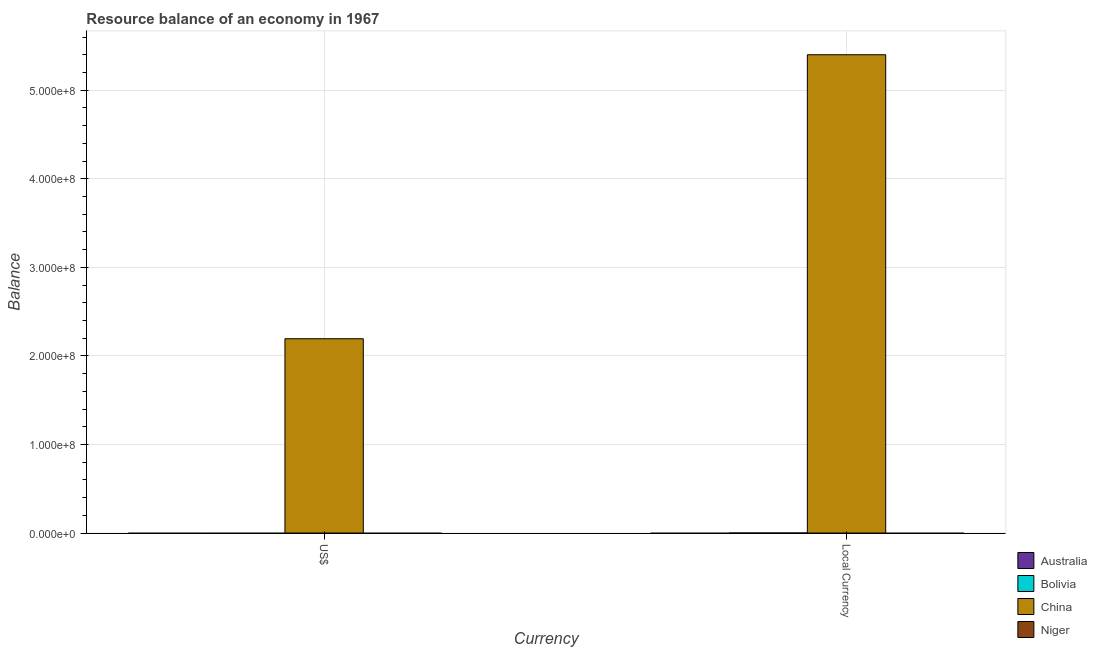How many different coloured bars are there?
Make the answer very short. 1. How many bars are there on the 1st tick from the right?
Offer a terse response. 1. What is the label of the 1st group of bars from the left?
Provide a succinct answer. US$. Across all countries, what is the maximum resource balance in constant us$?
Provide a succinct answer. 5.40e+08. What is the total resource balance in constant us$ in the graph?
Keep it short and to the point. 5.40e+08. What is the difference between the resource balance in us$ in Australia and the resource balance in constant us$ in Bolivia?
Provide a succinct answer. 0. What is the average resource balance in us$ per country?
Offer a very short reply. 5.48e+07. What is the difference between the resource balance in constant us$ and resource balance in us$ in China?
Your answer should be compact. 3.21e+08. In how many countries, is the resource balance in constant us$ greater than 500000000 units?
Provide a succinct answer. 1. How many bars are there?
Keep it short and to the point. 2. Are all the bars in the graph horizontal?
Offer a very short reply. No. How many countries are there in the graph?
Keep it short and to the point. 4. Are the values on the major ticks of Y-axis written in scientific E-notation?
Your response must be concise. Yes. Does the graph contain any zero values?
Keep it short and to the point. Yes. Where does the legend appear in the graph?
Offer a terse response. Bottom right. How many legend labels are there?
Your response must be concise. 4. How are the legend labels stacked?
Offer a very short reply. Vertical. What is the title of the graph?
Offer a terse response. Resource balance of an economy in 1967. What is the label or title of the X-axis?
Your answer should be compact. Currency. What is the label or title of the Y-axis?
Your answer should be compact. Balance. What is the Balance of Australia in US$?
Provide a short and direct response. 0. What is the Balance in China in US$?
Give a very brief answer. 2.19e+08. What is the Balance in Australia in Local Currency?
Your answer should be compact. 0. What is the Balance in Bolivia in Local Currency?
Keep it short and to the point. 0. What is the Balance in China in Local Currency?
Provide a short and direct response. 5.40e+08. What is the Balance of Niger in Local Currency?
Give a very brief answer. 0. Across all Currency, what is the maximum Balance in China?
Ensure brevity in your answer.  5.40e+08. Across all Currency, what is the minimum Balance in China?
Offer a terse response. 2.19e+08. What is the total Balance in China in the graph?
Offer a terse response. 7.59e+08. What is the difference between the Balance in China in US$ and that in Local Currency?
Your response must be concise. -3.21e+08. What is the average Balance in China per Currency?
Give a very brief answer. 3.80e+08. What is the average Balance of Niger per Currency?
Your answer should be compact. 0. What is the ratio of the Balance in China in US$ to that in Local Currency?
Your response must be concise. 0.41. What is the difference between the highest and the second highest Balance in China?
Ensure brevity in your answer.  3.21e+08. What is the difference between the highest and the lowest Balance of China?
Provide a short and direct response. 3.21e+08. 